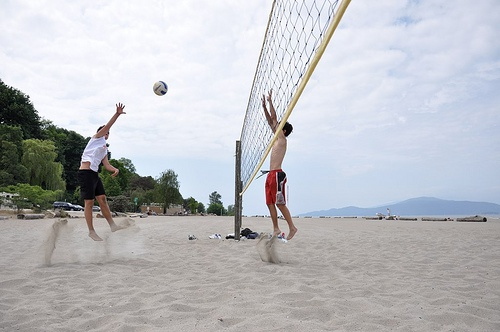Describe the objects in this image and their specific colors. I can see people in lavender, black, darkgray, and gray tones, people in lavender, gray, maroon, and black tones, sports ball in lavender, darkgray, gray, lightgray, and navy tones, car in lavender, black, gray, and darkgray tones, and car in lavender, gray, darkgray, and black tones in this image. 